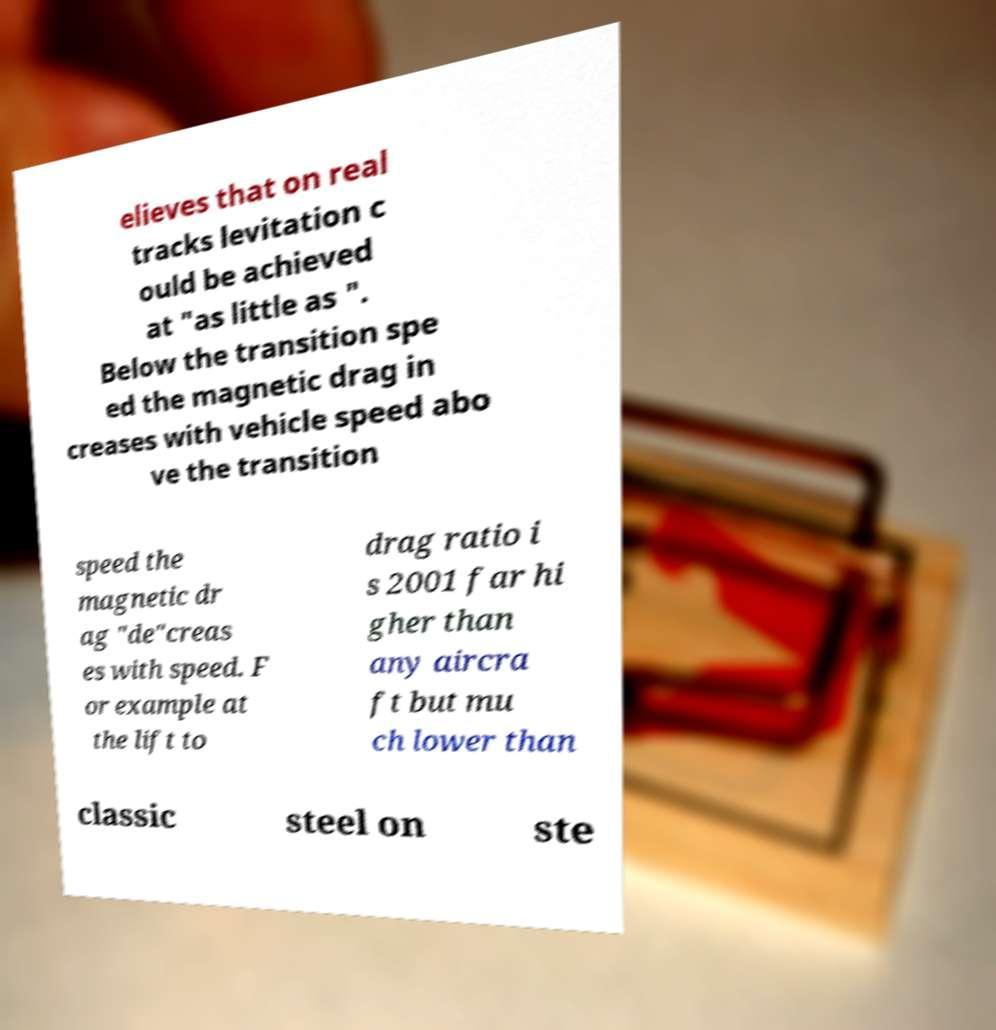Could you extract and type out the text from this image? elieves that on real tracks levitation c ould be achieved at "as little as ". Below the transition spe ed the magnetic drag in creases with vehicle speed abo ve the transition speed the magnetic dr ag "de"creas es with speed. F or example at the lift to drag ratio i s 2001 far hi gher than any aircra ft but mu ch lower than classic steel on ste 